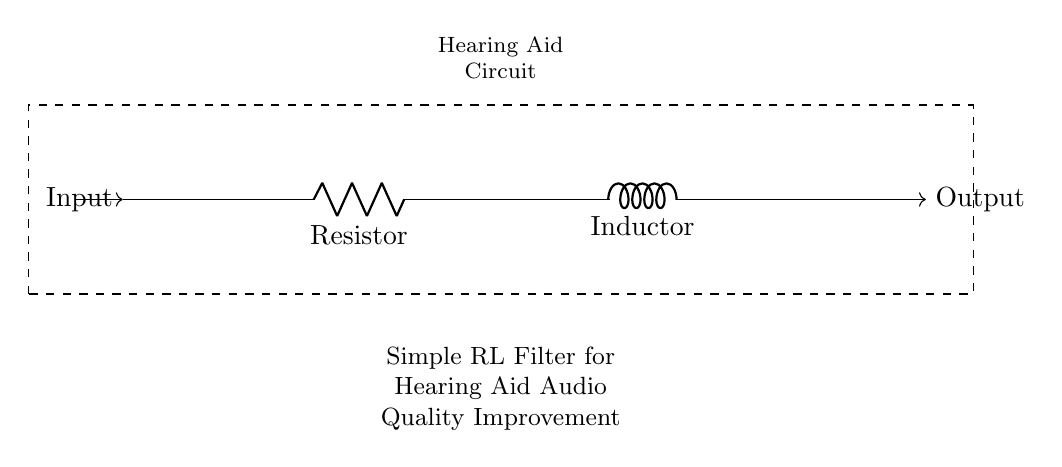What components are present in the circuit? The circuit diagram shows a resistor and an inductor connected in series. These are fundamental components of the filter.
Answer: Resistor, Inductor What type of circuit is depicted? The diagram represents a simple RL filter circuit, which is used to improve audio quality in hearing aids. The inclusion of the components indicates its type.
Answer: RL filter What is the function of the resistor in the circuit? The resistor limits the current flowing through the circuit, which can help reduce unwanted noise and improve audio clarity in the hearing aid.
Answer: Current limiter What is the purpose of the inductor in this circuit? The inductor stores energy in a magnetic field when current flows through it, helping to filter out high-frequency noise which can enhance audio quality.
Answer: Noise filtering How are the components connected? The resistor and inductor are connected in series, allowing the current to flow consecutively through both components as part of the filtering process.
Answer: In series What is the expected effect of this filter on audio signals? This RL filter typically attenuates high-frequency noise while allowing lower-frequency audio signals to pass, providing clearer sound for the user.
Answer: Clearer sound 